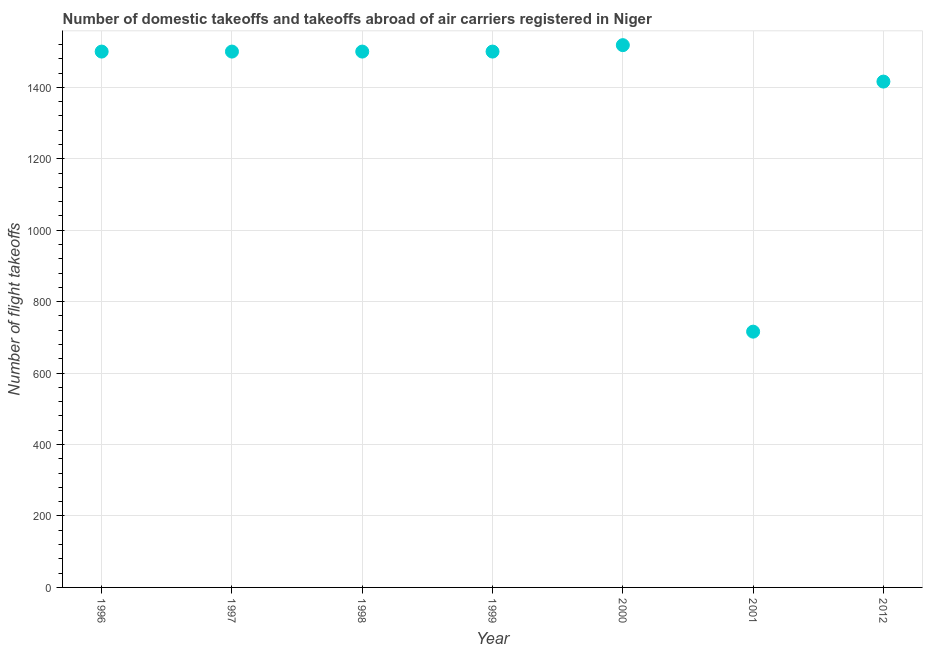What is the number of flight takeoffs in 2000?
Your answer should be compact. 1518. Across all years, what is the maximum number of flight takeoffs?
Keep it short and to the point. 1518. Across all years, what is the minimum number of flight takeoffs?
Give a very brief answer. 716. In which year was the number of flight takeoffs maximum?
Offer a terse response. 2000. What is the sum of the number of flight takeoffs?
Your answer should be compact. 9650. What is the difference between the number of flight takeoffs in 1998 and 2012?
Your answer should be very brief. 84. What is the average number of flight takeoffs per year?
Your answer should be compact. 1378.57. What is the median number of flight takeoffs?
Make the answer very short. 1500. In how many years, is the number of flight takeoffs greater than 160 ?
Your answer should be compact. 7. What is the ratio of the number of flight takeoffs in 1999 to that in 2000?
Provide a short and direct response. 0.99. Is the difference between the number of flight takeoffs in 1998 and 2012 greater than the difference between any two years?
Your answer should be very brief. No. What is the difference between the highest and the second highest number of flight takeoffs?
Provide a succinct answer. 18. What is the difference between the highest and the lowest number of flight takeoffs?
Your response must be concise. 802. In how many years, is the number of flight takeoffs greater than the average number of flight takeoffs taken over all years?
Ensure brevity in your answer.  6. Does the number of flight takeoffs monotonically increase over the years?
Provide a succinct answer. No. How many dotlines are there?
Your answer should be compact. 1. How many years are there in the graph?
Your answer should be very brief. 7. What is the title of the graph?
Keep it short and to the point. Number of domestic takeoffs and takeoffs abroad of air carriers registered in Niger. What is the label or title of the Y-axis?
Ensure brevity in your answer.  Number of flight takeoffs. What is the Number of flight takeoffs in 1996?
Provide a succinct answer. 1500. What is the Number of flight takeoffs in 1997?
Ensure brevity in your answer.  1500. What is the Number of flight takeoffs in 1998?
Provide a succinct answer. 1500. What is the Number of flight takeoffs in 1999?
Offer a very short reply. 1500. What is the Number of flight takeoffs in 2000?
Your answer should be very brief. 1518. What is the Number of flight takeoffs in 2001?
Ensure brevity in your answer.  716. What is the Number of flight takeoffs in 2012?
Your response must be concise. 1416. What is the difference between the Number of flight takeoffs in 1996 and 1997?
Offer a very short reply. 0. What is the difference between the Number of flight takeoffs in 1996 and 2000?
Your answer should be compact. -18. What is the difference between the Number of flight takeoffs in 1996 and 2001?
Provide a short and direct response. 784. What is the difference between the Number of flight takeoffs in 1997 and 1998?
Offer a very short reply. 0. What is the difference between the Number of flight takeoffs in 1997 and 2000?
Make the answer very short. -18. What is the difference between the Number of flight takeoffs in 1997 and 2001?
Your response must be concise. 784. What is the difference between the Number of flight takeoffs in 1998 and 1999?
Provide a short and direct response. 0. What is the difference between the Number of flight takeoffs in 1998 and 2000?
Offer a terse response. -18. What is the difference between the Number of flight takeoffs in 1998 and 2001?
Offer a very short reply. 784. What is the difference between the Number of flight takeoffs in 1998 and 2012?
Offer a terse response. 84. What is the difference between the Number of flight takeoffs in 1999 and 2001?
Provide a short and direct response. 784. What is the difference between the Number of flight takeoffs in 2000 and 2001?
Offer a terse response. 802. What is the difference between the Number of flight takeoffs in 2000 and 2012?
Your response must be concise. 102. What is the difference between the Number of flight takeoffs in 2001 and 2012?
Provide a short and direct response. -700. What is the ratio of the Number of flight takeoffs in 1996 to that in 2001?
Your response must be concise. 2.1. What is the ratio of the Number of flight takeoffs in 1996 to that in 2012?
Provide a short and direct response. 1.06. What is the ratio of the Number of flight takeoffs in 1997 to that in 1998?
Make the answer very short. 1. What is the ratio of the Number of flight takeoffs in 1997 to that in 1999?
Make the answer very short. 1. What is the ratio of the Number of flight takeoffs in 1997 to that in 2000?
Keep it short and to the point. 0.99. What is the ratio of the Number of flight takeoffs in 1997 to that in 2001?
Your answer should be compact. 2.1. What is the ratio of the Number of flight takeoffs in 1997 to that in 2012?
Provide a short and direct response. 1.06. What is the ratio of the Number of flight takeoffs in 1998 to that in 2000?
Ensure brevity in your answer.  0.99. What is the ratio of the Number of flight takeoffs in 1998 to that in 2001?
Your answer should be compact. 2.1. What is the ratio of the Number of flight takeoffs in 1998 to that in 2012?
Make the answer very short. 1.06. What is the ratio of the Number of flight takeoffs in 1999 to that in 2001?
Ensure brevity in your answer.  2.1. What is the ratio of the Number of flight takeoffs in 1999 to that in 2012?
Your answer should be very brief. 1.06. What is the ratio of the Number of flight takeoffs in 2000 to that in 2001?
Your answer should be compact. 2.12. What is the ratio of the Number of flight takeoffs in 2000 to that in 2012?
Offer a terse response. 1.07. What is the ratio of the Number of flight takeoffs in 2001 to that in 2012?
Ensure brevity in your answer.  0.51. 